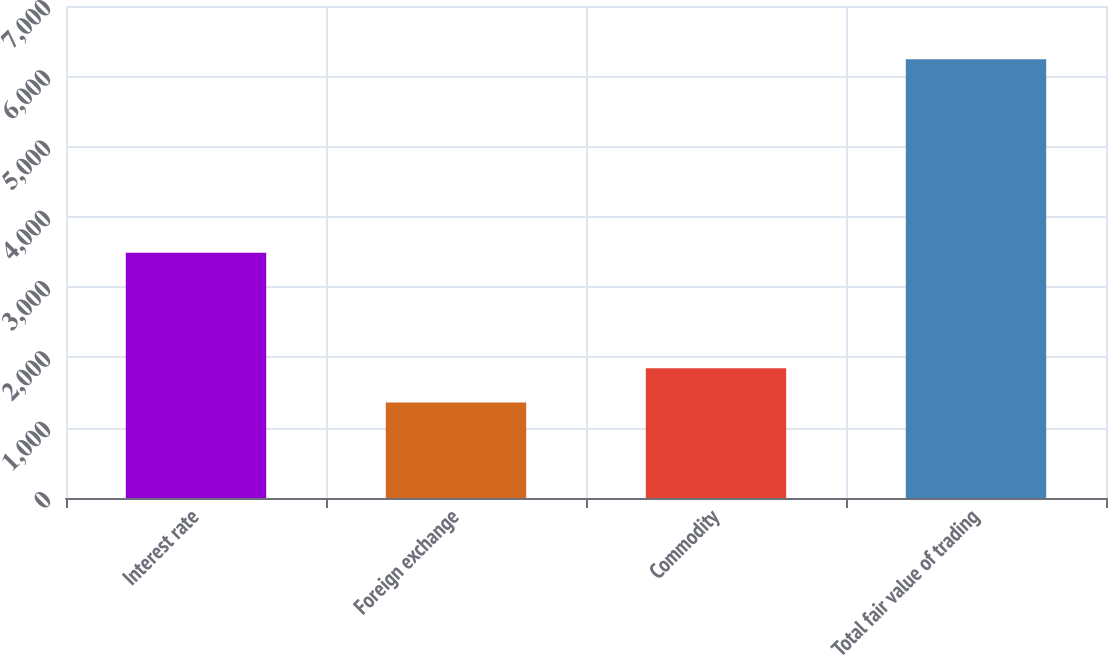Convert chart to OTSL. <chart><loc_0><loc_0><loc_500><loc_500><bar_chart><fcel>Interest rate<fcel>Foreign exchange<fcel>Commodity<fcel>Total fair value of trading<nl><fcel>3490<fcel>1359<fcel>1847.4<fcel>6243<nl></chart> 